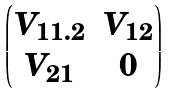Convert formula to latex. <formula><loc_0><loc_0><loc_500><loc_500>\begin{pmatrix} V _ { 1 1 . 2 } & V _ { 1 2 } \\ V _ { 2 1 } & 0 \\ \end{pmatrix}</formula> 